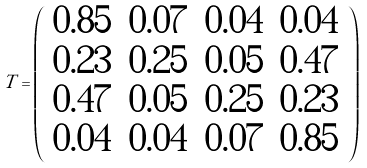<formula> <loc_0><loc_0><loc_500><loc_500>T = \left ( \begin{array} { c c c c } 0 . 8 5 & 0 . 0 7 & 0 . 0 4 & 0 . 0 4 \\ 0 . 2 3 & 0 . 2 5 & 0 . 0 5 & 0 . 4 7 \\ 0 . 4 7 & 0 . 0 5 & 0 . 2 5 & 0 . 2 3 \\ 0 . 0 4 & 0 . 0 4 & 0 . 0 7 & 0 . 8 5 \\ \end{array} \right )</formula> 